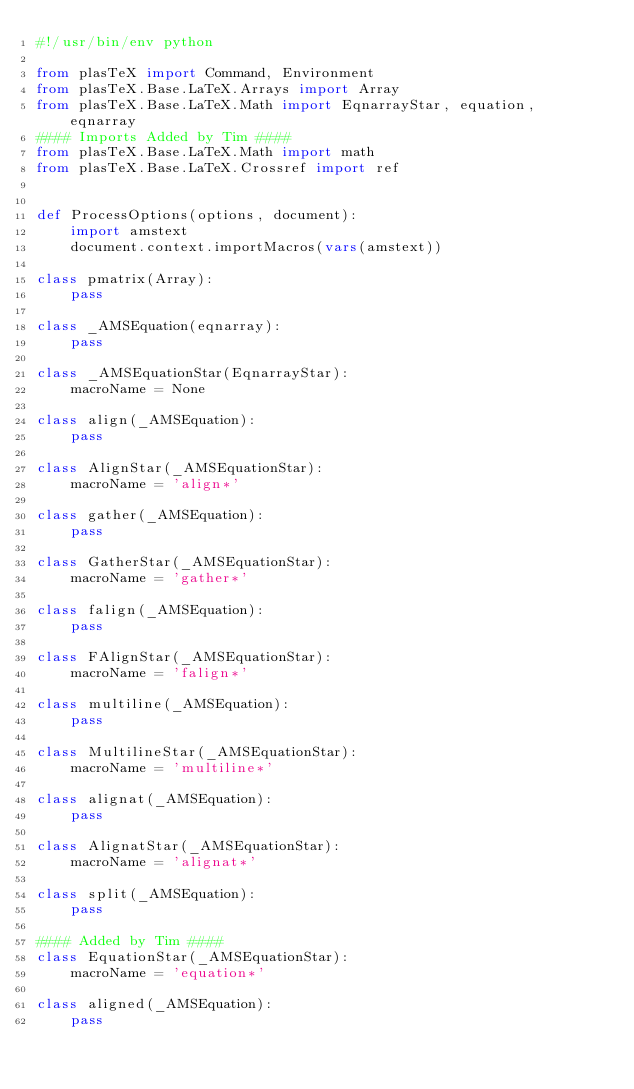Convert code to text. <code><loc_0><loc_0><loc_500><loc_500><_Python_>#!/usr/bin/env python

from plasTeX import Command, Environment
from plasTeX.Base.LaTeX.Arrays import Array
from plasTeX.Base.LaTeX.Math import EqnarrayStar, equation, eqnarray
#### Imports Added by Tim ####
from plasTeX.Base.LaTeX.Math import math
from plasTeX.Base.LaTeX.Crossref import ref


def ProcessOptions(options, document):
    import amstext
    document.context.importMacros(vars(amstext))

class pmatrix(Array):
    pass

class _AMSEquation(eqnarray):
    pass

class _AMSEquationStar(EqnarrayStar):
    macroName = None

class align(_AMSEquation):
    pass

class AlignStar(_AMSEquationStar):
    macroName = 'align*'

class gather(_AMSEquation):
    pass

class GatherStar(_AMSEquationStar):
    macroName = 'gather*'

class falign(_AMSEquation):
    pass

class FAlignStar(_AMSEquationStar):
    macroName = 'falign*'

class multiline(_AMSEquation):
    pass

class MultilineStar(_AMSEquationStar):
    macroName = 'multiline*'

class alignat(_AMSEquation):
    pass

class AlignatStar(_AMSEquationStar):
    macroName = 'alignat*'

class split(_AMSEquation):
    pass

#### Added by Tim ####
class EquationStar(_AMSEquationStar):
    macroName = 'equation*'

class aligned(_AMSEquation):
    pass
</code> 